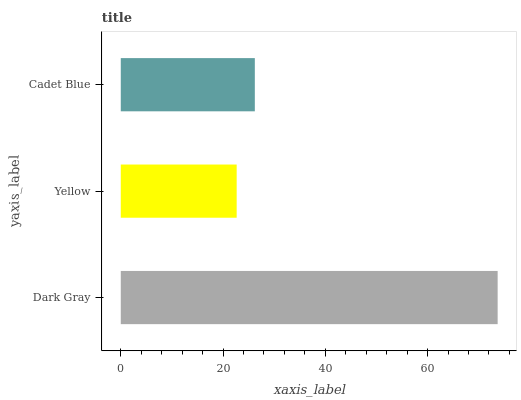Is Yellow the minimum?
Answer yes or no. Yes. Is Dark Gray the maximum?
Answer yes or no. Yes. Is Cadet Blue the minimum?
Answer yes or no. No. Is Cadet Blue the maximum?
Answer yes or no. No. Is Cadet Blue greater than Yellow?
Answer yes or no. Yes. Is Yellow less than Cadet Blue?
Answer yes or no. Yes. Is Yellow greater than Cadet Blue?
Answer yes or no. No. Is Cadet Blue less than Yellow?
Answer yes or no. No. Is Cadet Blue the high median?
Answer yes or no. Yes. Is Cadet Blue the low median?
Answer yes or no. Yes. Is Dark Gray the high median?
Answer yes or no. No. Is Dark Gray the low median?
Answer yes or no. No. 